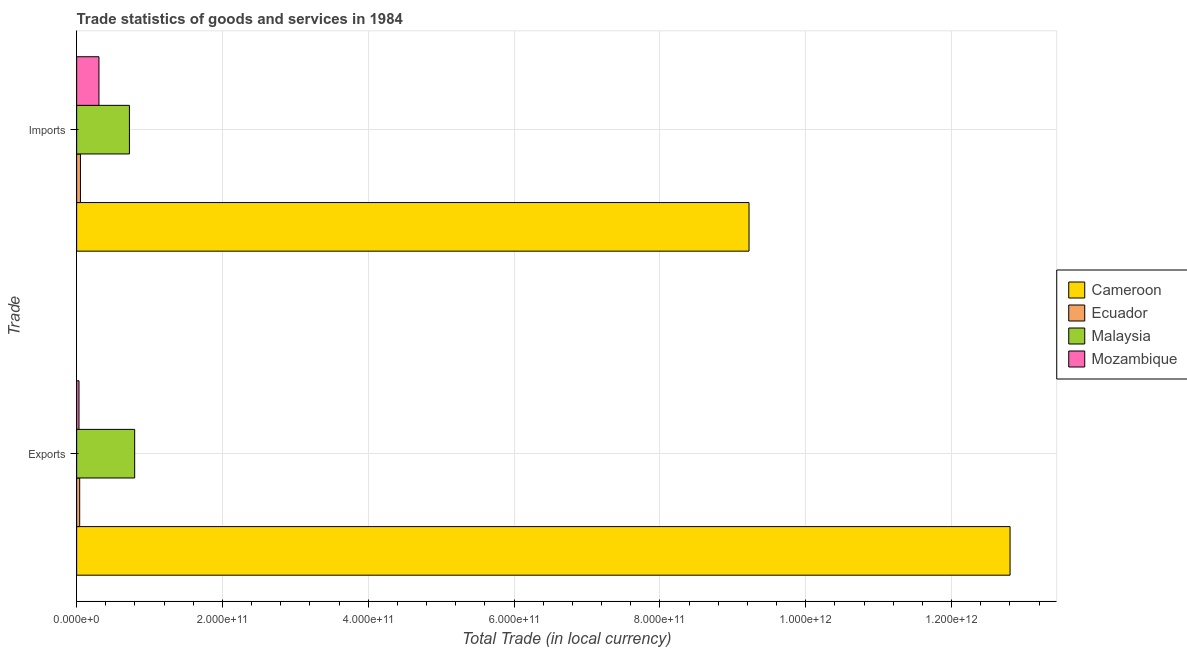How many different coloured bars are there?
Keep it short and to the point. 4. Are the number of bars per tick equal to the number of legend labels?
Keep it short and to the point. Yes. Are the number of bars on each tick of the Y-axis equal?
Your response must be concise. Yes. How many bars are there on the 2nd tick from the top?
Your response must be concise. 4. What is the label of the 2nd group of bars from the top?
Your answer should be very brief. Exports. What is the imports of goods and services in Mozambique?
Your answer should be very brief. 3.06e+1. Across all countries, what is the maximum imports of goods and services?
Your answer should be very brief. 9.22e+11. Across all countries, what is the minimum export of goods and services?
Your answer should be very brief. 3.22e+09. In which country was the export of goods and services maximum?
Provide a succinct answer. Cameroon. In which country was the export of goods and services minimum?
Offer a terse response. Mozambique. What is the total imports of goods and services in the graph?
Provide a succinct answer. 1.03e+12. What is the difference between the imports of goods and services in Mozambique and that in Malaysia?
Make the answer very short. -4.18e+1. What is the difference between the export of goods and services in Malaysia and the imports of goods and services in Mozambique?
Ensure brevity in your answer.  4.90e+1. What is the average export of goods and services per country?
Offer a very short reply. 3.42e+11. What is the difference between the export of goods and services and imports of goods and services in Ecuador?
Provide a short and direct response. -1.03e+09. In how many countries, is the export of goods and services greater than 1200000000000 LCU?
Your answer should be compact. 1. What is the ratio of the imports of goods and services in Mozambique to that in Cameroon?
Offer a very short reply. 0.03. Is the imports of goods and services in Malaysia less than that in Ecuador?
Keep it short and to the point. No. What does the 1st bar from the top in Exports represents?
Ensure brevity in your answer.  Mozambique. What does the 1st bar from the bottom in Exports represents?
Offer a very short reply. Cameroon. How many bars are there?
Your answer should be compact. 8. How many countries are there in the graph?
Offer a terse response. 4. What is the difference between two consecutive major ticks on the X-axis?
Ensure brevity in your answer.  2.00e+11. Does the graph contain grids?
Provide a short and direct response. Yes. How many legend labels are there?
Offer a very short reply. 4. How are the legend labels stacked?
Keep it short and to the point. Vertical. What is the title of the graph?
Make the answer very short. Trade statistics of goods and services in 1984. What is the label or title of the X-axis?
Your answer should be compact. Total Trade (in local currency). What is the label or title of the Y-axis?
Offer a terse response. Trade. What is the Total Trade (in local currency) in Cameroon in Exports?
Provide a short and direct response. 1.28e+12. What is the Total Trade (in local currency) of Ecuador in Exports?
Your response must be concise. 4.15e+09. What is the Total Trade (in local currency) of Malaysia in Exports?
Your answer should be compact. 7.96e+1. What is the Total Trade (in local currency) of Mozambique in Exports?
Keep it short and to the point. 3.22e+09. What is the Total Trade (in local currency) in Cameroon in Imports?
Provide a succinct answer. 9.22e+11. What is the Total Trade (in local currency) in Ecuador in Imports?
Keep it short and to the point. 5.19e+09. What is the Total Trade (in local currency) of Malaysia in Imports?
Make the answer very short. 7.24e+1. What is the Total Trade (in local currency) in Mozambique in Imports?
Provide a short and direct response. 3.06e+1. Across all Trade, what is the maximum Total Trade (in local currency) in Cameroon?
Ensure brevity in your answer.  1.28e+12. Across all Trade, what is the maximum Total Trade (in local currency) in Ecuador?
Make the answer very short. 5.19e+09. Across all Trade, what is the maximum Total Trade (in local currency) in Malaysia?
Offer a terse response. 7.96e+1. Across all Trade, what is the maximum Total Trade (in local currency) of Mozambique?
Keep it short and to the point. 3.06e+1. Across all Trade, what is the minimum Total Trade (in local currency) of Cameroon?
Your answer should be very brief. 9.22e+11. Across all Trade, what is the minimum Total Trade (in local currency) in Ecuador?
Offer a terse response. 4.15e+09. Across all Trade, what is the minimum Total Trade (in local currency) in Malaysia?
Offer a terse response. 7.24e+1. Across all Trade, what is the minimum Total Trade (in local currency) in Mozambique?
Ensure brevity in your answer.  3.22e+09. What is the total Total Trade (in local currency) of Cameroon in the graph?
Provide a succinct answer. 2.20e+12. What is the total Total Trade (in local currency) of Ecuador in the graph?
Ensure brevity in your answer.  9.34e+09. What is the total Total Trade (in local currency) of Malaysia in the graph?
Ensure brevity in your answer.  1.52e+11. What is the total Total Trade (in local currency) in Mozambique in the graph?
Provide a succinct answer. 3.38e+1. What is the difference between the Total Trade (in local currency) of Cameroon in Exports and that in Imports?
Provide a short and direct response. 3.58e+11. What is the difference between the Total Trade (in local currency) in Ecuador in Exports and that in Imports?
Your answer should be compact. -1.03e+09. What is the difference between the Total Trade (in local currency) in Malaysia in Exports and that in Imports?
Offer a terse response. 7.20e+09. What is the difference between the Total Trade (in local currency) of Mozambique in Exports and that in Imports?
Offer a very short reply. -2.74e+1. What is the difference between the Total Trade (in local currency) in Cameroon in Exports and the Total Trade (in local currency) in Ecuador in Imports?
Your answer should be compact. 1.28e+12. What is the difference between the Total Trade (in local currency) in Cameroon in Exports and the Total Trade (in local currency) in Malaysia in Imports?
Make the answer very short. 1.21e+12. What is the difference between the Total Trade (in local currency) in Cameroon in Exports and the Total Trade (in local currency) in Mozambique in Imports?
Make the answer very short. 1.25e+12. What is the difference between the Total Trade (in local currency) of Ecuador in Exports and the Total Trade (in local currency) of Malaysia in Imports?
Your response must be concise. -6.82e+1. What is the difference between the Total Trade (in local currency) of Ecuador in Exports and the Total Trade (in local currency) of Mozambique in Imports?
Make the answer very short. -2.64e+1. What is the difference between the Total Trade (in local currency) of Malaysia in Exports and the Total Trade (in local currency) of Mozambique in Imports?
Your answer should be very brief. 4.90e+1. What is the average Total Trade (in local currency) of Cameroon per Trade?
Make the answer very short. 1.10e+12. What is the average Total Trade (in local currency) of Ecuador per Trade?
Offer a very short reply. 4.67e+09. What is the average Total Trade (in local currency) of Malaysia per Trade?
Provide a succinct answer. 7.60e+1. What is the average Total Trade (in local currency) of Mozambique per Trade?
Make the answer very short. 1.69e+1. What is the difference between the Total Trade (in local currency) in Cameroon and Total Trade (in local currency) in Ecuador in Exports?
Give a very brief answer. 1.28e+12. What is the difference between the Total Trade (in local currency) in Cameroon and Total Trade (in local currency) in Malaysia in Exports?
Make the answer very short. 1.20e+12. What is the difference between the Total Trade (in local currency) of Cameroon and Total Trade (in local currency) of Mozambique in Exports?
Give a very brief answer. 1.28e+12. What is the difference between the Total Trade (in local currency) of Ecuador and Total Trade (in local currency) of Malaysia in Exports?
Offer a terse response. -7.54e+1. What is the difference between the Total Trade (in local currency) in Ecuador and Total Trade (in local currency) in Mozambique in Exports?
Ensure brevity in your answer.  9.33e+08. What is the difference between the Total Trade (in local currency) in Malaysia and Total Trade (in local currency) in Mozambique in Exports?
Your answer should be compact. 7.63e+1. What is the difference between the Total Trade (in local currency) in Cameroon and Total Trade (in local currency) in Ecuador in Imports?
Provide a short and direct response. 9.17e+11. What is the difference between the Total Trade (in local currency) of Cameroon and Total Trade (in local currency) of Malaysia in Imports?
Your answer should be very brief. 8.50e+11. What is the difference between the Total Trade (in local currency) in Cameroon and Total Trade (in local currency) in Mozambique in Imports?
Provide a succinct answer. 8.92e+11. What is the difference between the Total Trade (in local currency) of Ecuador and Total Trade (in local currency) of Malaysia in Imports?
Your answer should be compact. -6.72e+1. What is the difference between the Total Trade (in local currency) in Ecuador and Total Trade (in local currency) in Mozambique in Imports?
Keep it short and to the point. -2.54e+1. What is the difference between the Total Trade (in local currency) of Malaysia and Total Trade (in local currency) of Mozambique in Imports?
Your response must be concise. 4.18e+1. What is the ratio of the Total Trade (in local currency) of Cameroon in Exports to that in Imports?
Your answer should be compact. 1.39. What is the ratio of the Total Trade (in local currency) of Ecuador in Exports to that in Imports?
Your response must be concise. 0.8. What is the ratio of the Total Trade (in local currency) in Malaysia in Exports to that in Imports?
Your response must be concise. 1.1. What is the ratio of the Total Trade (in local currency) in Mozambique in Exports to that in Imports?
Your answer should be compact. 0.11. What is the difference between the highest and the second highest Total Trade (in local currency) of Cameroon?
Ensure brevity in your answer.  3.58e+11. What is the difference between the highest and the second highest Total Trade (in local currency) of Ecuador?
Your response must be concise. 1.03e+09. What is the difference between the highest and the second highest Total Trade (in local currency) of Malaysia?
Your answer should be very brief. 7.20e+09. What is the difference between the highest and the second highest Total Trade (in local currency) of Mozambique?
Ensure brevity in your answer.  2.74e+1. What is the difference between the highest and the lowest Total Trade (in local currency) in Cameroon?
Provide a succinct answer. 3.58e+11. What is the difference between the highest and the lowest Total Trade (in local currency) in Ecuador?
Ensure brevity in your answer.  1.03e+09. What is the difference between the highest and the lowest Total Trade (in local currency) of Malaysia?
Your answer should be very brief. 7.20e+09. What is the difference between the highest and the lowest Total Trade (in local currency) of Mozambique?
Provide a succinct answer. 2.74e+1. 